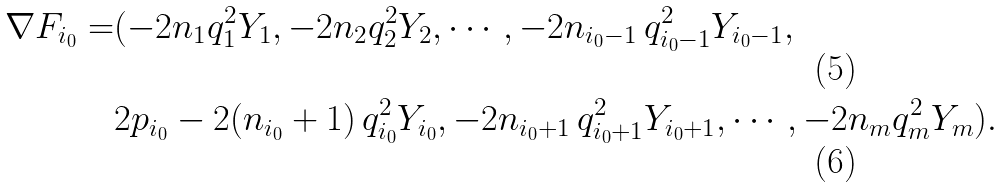<formula> <loc_0><loc_0><loc_500><loc_500>\nabla F _ { i _ { 0 } } = & ( - 2 n _ { 1 } q _ { 1 } ^ { 2 } Y _ { 1 } , - 2 n _ { 2 } q _ { 2 } ^ { 2 } Y _ { 2 } , \cdots , - 2 n _ { i _ { 0 } - 1 } \, q _ { i _ { 0 } - 1 } ^ { 2 } Y _ { i _ { 0 } - 1 } , \\ & 2 p _ { i _ { 0 } } - 2 ( n _ { i _ { 0 } } + 1 ) \, q _ { i _ { 0 } } ^ { 2 } Y _ { i _ { 0 } } , - 2 n _ { i _ { 0 } + 1 } \, q _ { i _ { 0 } + 1 } ^ { 2 } Y _ { i _ { 0 } + 1 } , \cdots , - 2 n _ { m } q _ { m } ^ { 2 } Y _ { m } ) .</formula> 